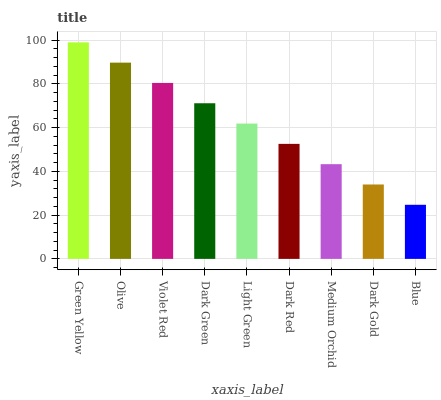Is Blue the minimum?
Answer yes or no. Yes. Is Green Yellow the maximum?
Answer yes or no. Yes. Is Olive the minimum?
Answer yes or no. No. Is Olive the maximum?
Answer yes or no. No. Is Green Yellow greater than Olive?
Answer yes or no. Yes. Is Olive less than Green Yellow?
Answer yes or no. Yes. Is Olive greater than Green Yellow?
Answer yes or no. No. Is Green Yellow less than Olive?
Answer yes or no. No. Is Light Green the high median?
Answer yes or no. Yes. Is Light Green the low median?
Answer yes or no. Yes. Is Medium Orchid the high median?
Answer yes or no. No. Is Green Yellow the low median?
Answer yes or no. No. 